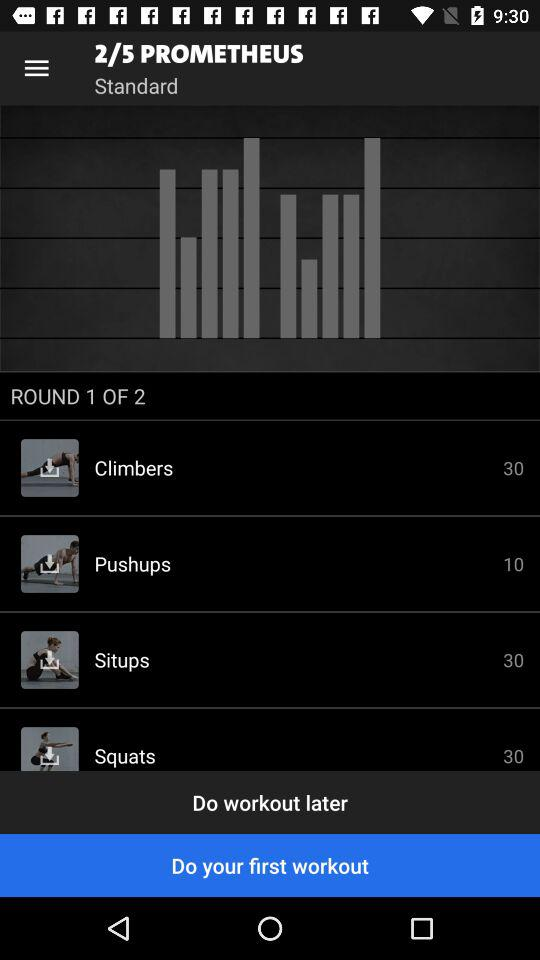Which round is going on? It is the first round that is going on. 